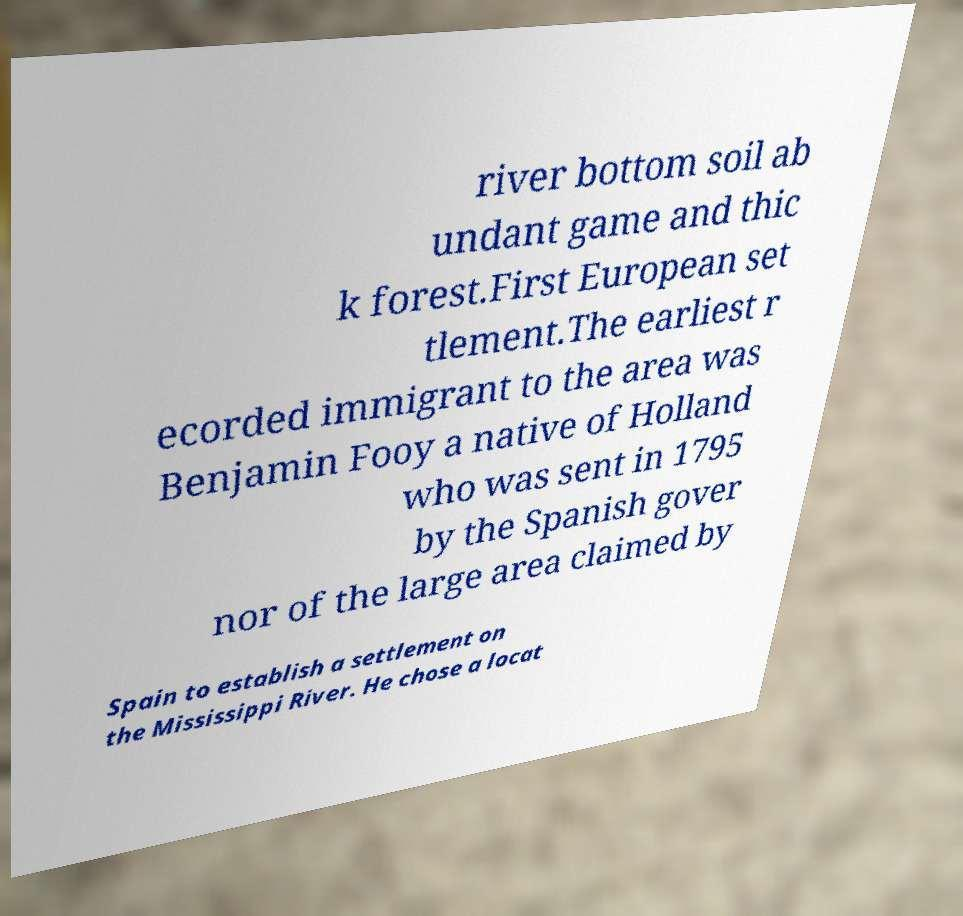What messages or text are displayed in this image? I need them in a readable, typed format. river bottom soil ab undant game and thic k forest.First European set tlement.The earliest r ecorded immigrant to the area was Benjamin Fooy a native of Holland who was sent in 1795 by the Spanish gover nor of the large area claimed by Spain to establish a settlement on the Mississippi River. He chose a locat 